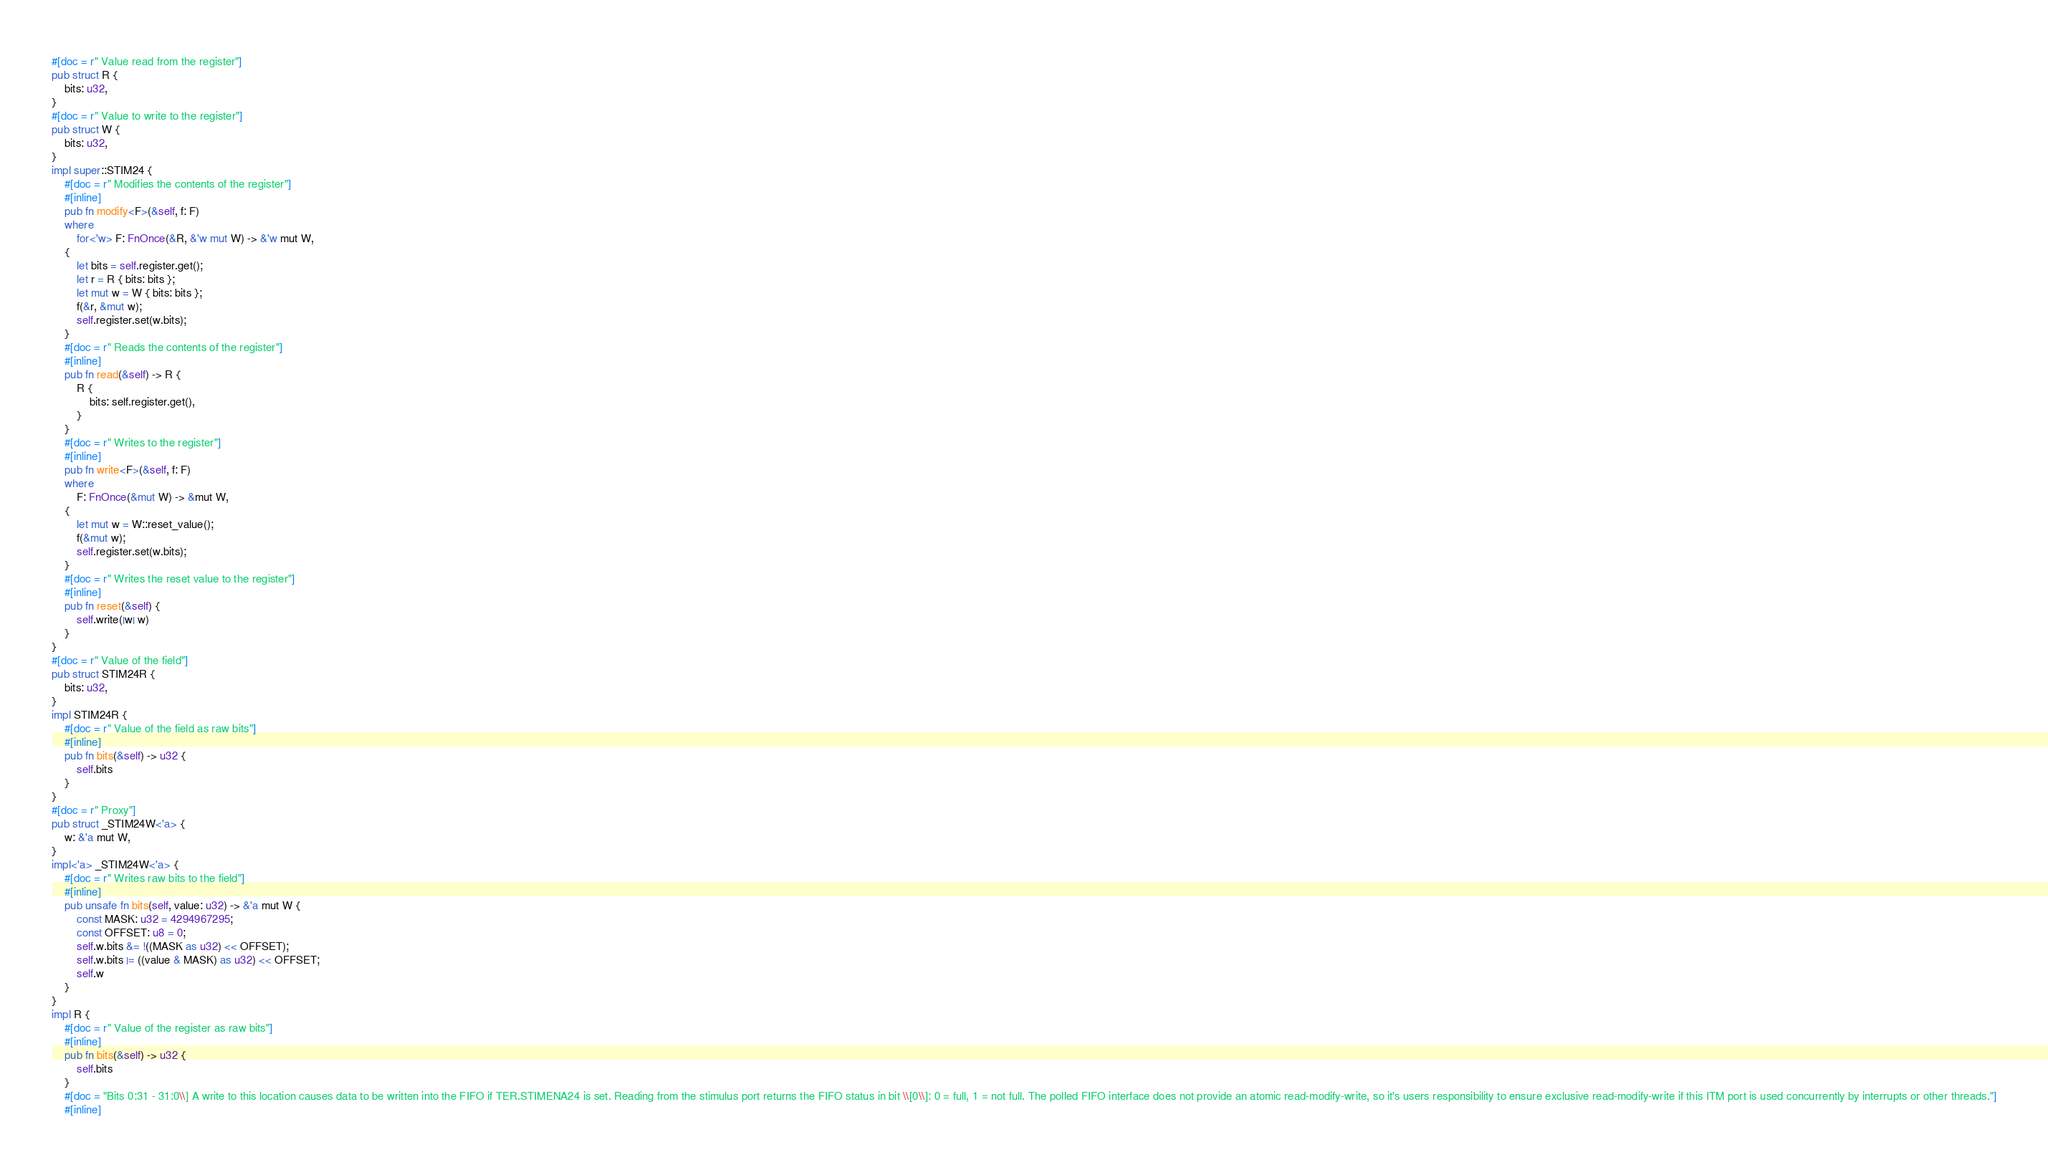<code> <loc_0><loc_0><loc_500><loc_500><_Rust_>#[doc = r" Value read from the register"]
pub struct R {
    bits: u32,
}
#[doc = r" Value to write to the register"]
pub struct W {
    bits: u32,
}
impl super::STIM24 {
    #[doc = r" Modifies the contents of the register"]
    #[inline]
    pub fn modify<F>(&self, f: F)
    where
        for<'w> F: FnOnce(&R, &'w mut W) -> &'w mut W,
    {
        let bits = self.register.get();
        let r = R { bits: bits };
        let mut w = W { bits: bits };
        f(&r, &mut w);
        self.register.set(w.bits);
    }
    #[doc = r" Reads the contents of the register"]
    #[inline]
    pub fn read(&self) -> R {
        R {
            bits: self.register.get(),
        }
    }
    #[doc = r" Writes to the register"]
    #[inline]
    pub fn write<F>(&self, f: F)
    where
        F: FnOnce(&mut W) -> &mut W,
    {
        let mut w = W::reset_value();
        f(&mut w);
        self.register.set(w.bits);
    }
    #[doc = r" Writes the reset value to the register"]
    #[inline]
    pub fn reset(&self) {
        self.write(|w| w)
    }
}
#[doc = r" Value of the field"]
pub struct STIM24R {
    bits: u32,
}
impl STIM24R {
    #[doc = r" Value of the field as raw bits"]
    #[inline]
    pub fn bits(&self) -> u32 {
        self.bits
    }
}
#[doc = r" Proxy"]
pub struct _STIM24W<'a> {
    w: &'a mut W,
}
impl<'a> _STIM24W<'a> {
    #[doc = r" Writes raw bits to the field"]
    #[inline]
    pub unsafe fn bits(self, value: u32) -> &'a mut W {
        const MASK: u32 = 4294967295;
        const OFFSET: u8 = 0;
        self.w.bits &= !((MASK as u32) << OFFSET);
        self.w.bits |= ((value & MASK) as u32) << OFFSET;
        self.w
    }
}
impl R {
    #[doc = r" Value of the register as raw bits"]
    #[inline]
    pub fn bits(&self) -> u32 {
        self.bits
    }
    #[doc = "Bits 0:31 - 31:0\\] A write to this location causes data to be written into the FIFO if TER.STIMENA24 is set. Reading from the stimulus port returns the FIFO status in bit \\[0\\]: 0 = full, 1 = not full. The polled FIFO interface does not provide an atomic read-modify-write, so it's users responsibility to ensure exclusive read-modify-write if this ITM port is used concurrently by interrupts or other threads."]
    #[inline]</code> 